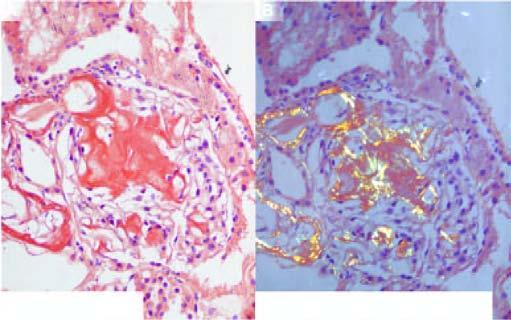what do the congophilic areas show?
Answer the question using a single word or phrase. Apple-green birefringence 